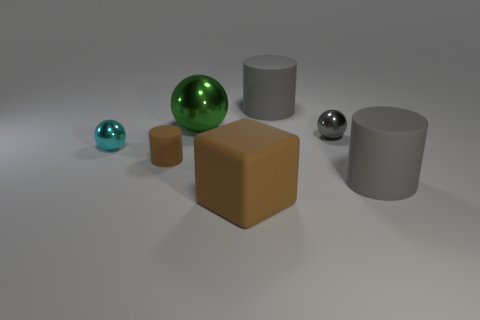Add 2 tiny cyan balls. How many objects exist? 9 Subtract all cylinders. How many objects are left? 4 Add 7 tiny cyan metallic objects. How many tiny cyan metallic objects exist? 8 Subtract 1 cyan spheres. How many objects are left? 6 Subtract all brown matte balls. Subtract all small cyan metallic objects. How many objects are left? 6 Add 6 tiny matte things. How many tiny matte things are left? 7 